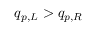Convert formula to latex. <formula><loc_0><loc_0><loc_500><loc_500>q _ { p , L } > q _ { p , R }</formula> 